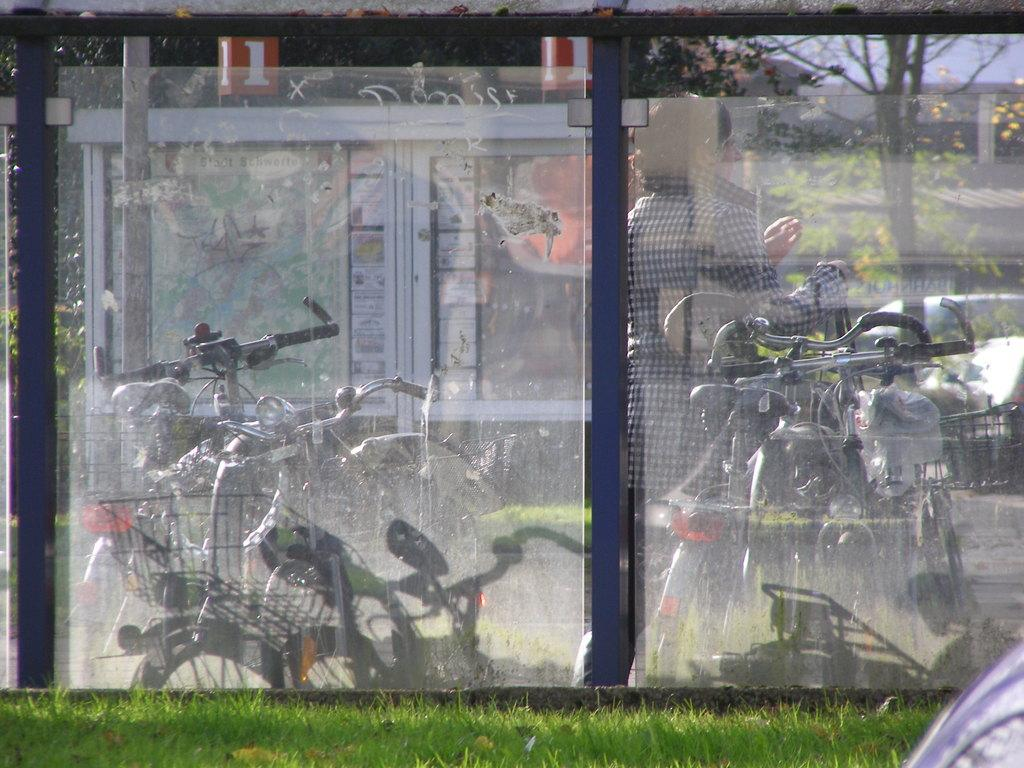What is the main object in the center of the image? There is a mirror in the center of the image. What does the mirror reflect in the image? The mirror reflects bicycles and a lady. What type of surface is visible at the bottom of the image? There is grass at the bottom of the image. What type of insurance policy is being discussed in the image? There is no discussion of insurance policies in the image; it features a mirror reflecting bicycles and a lady, with grass at the bottom. 